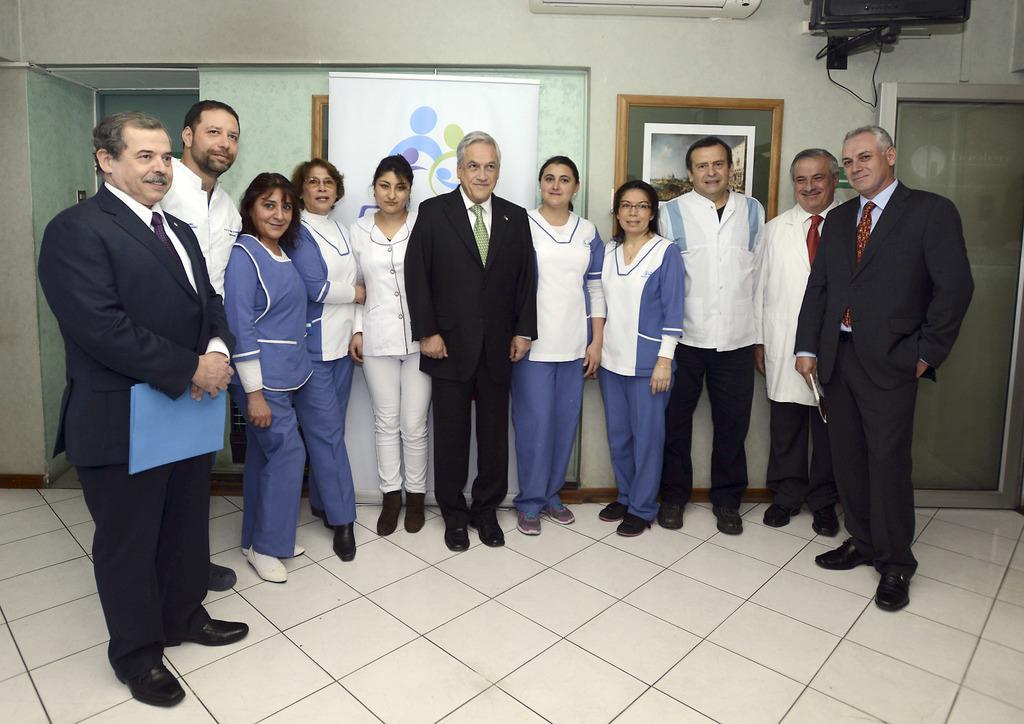Can you describe this image briefly? In this picture we can see a group of people standing on the floor. There are two men holding objects in their hands on the right and left side of the image. We can see a frame, some art on a white surface, glass object and a few objects on top of the picture. A wall is visible in the background. 